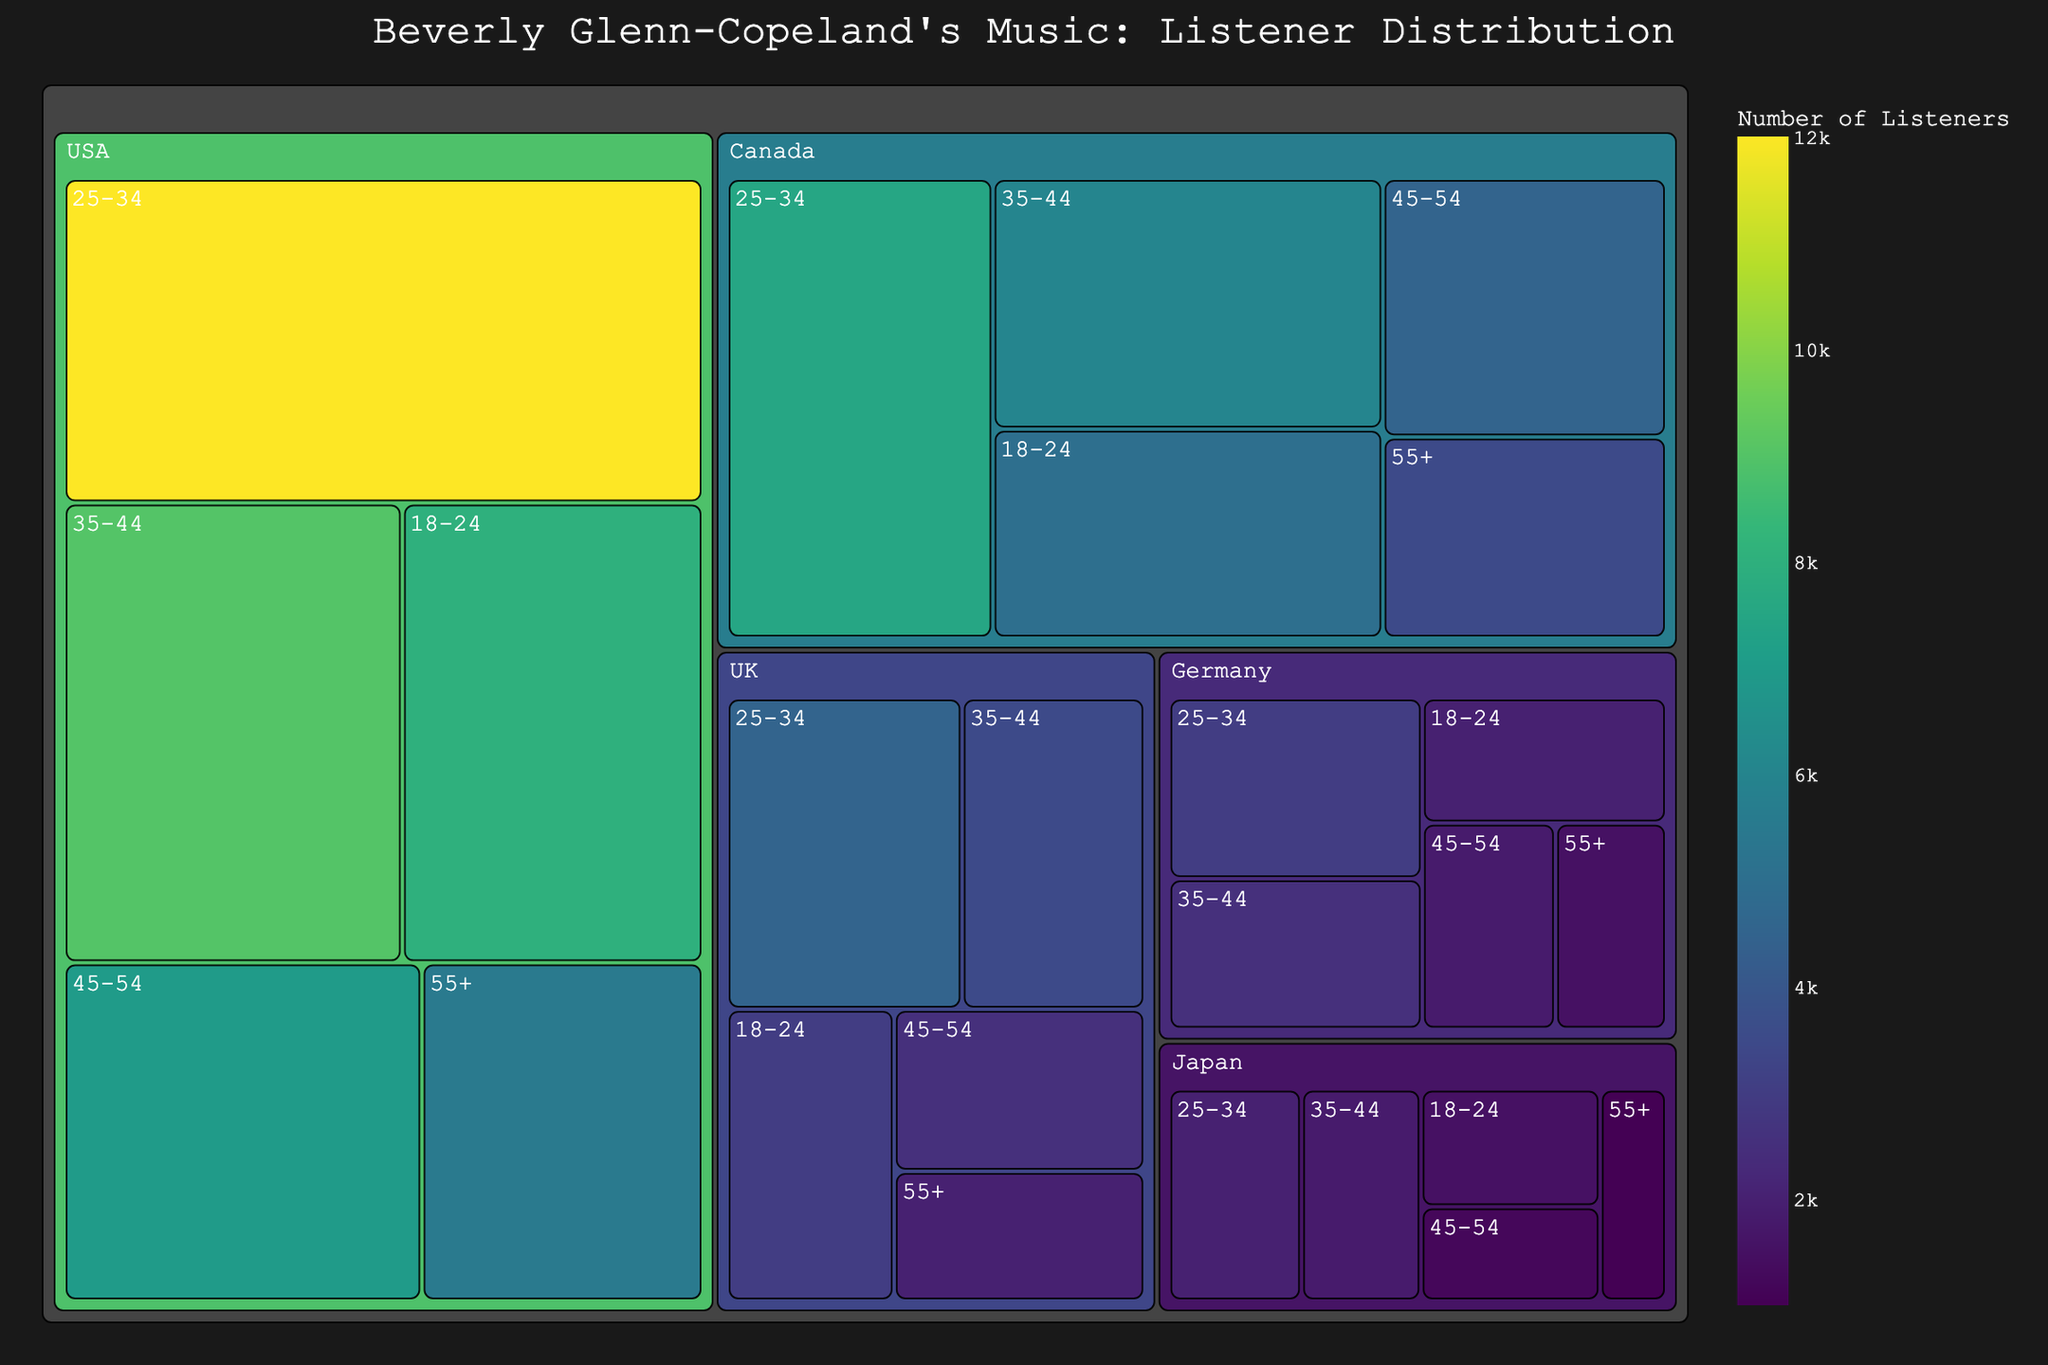What is the total number of listeners in Canada for Beverly Glenn-Copeland's music? Sum of Canadian listeners: 5000 (18-24) + 7500 (25-34) + 6000 (35-44) + 4500 (45-54) + 3500 (55+) = 26500
Answer: 26500 Which age group in the USA has the highest number of listeners? The USA age group with the highest number of listeners is 25-34 with 12000 listeners.
Answer: 25-34 Which country has the fewest listeners for the 55+ age group? Japan has the fewest listeners in the 55+ age group with 1000 listeners.
Answer: Japan How many more listeners are there in the UK's largest age group compared to its smallest age group? The UK's largest age group is 25-34 with 4500 listeners, and the smallest is 55+ with 2000 listeners. Difference: 4500 - 2000 = 2500
Answer: 2500 What is the proportion of listeners in the 18-24 age group in Germany compared to the total number of German listeners? Total listeners in Germany: 2000 (18-24) + 3000 (25-34) + 2500 (35-44) + 1800 (45-54) + 1500 (55+) = 10800. Proportion: 2000 / 10800 * 100% = 18.52%
Answer: 18.52% In which age group does Japan have the second lowest number of listeners? The second lowest number of listeners in Japan is in the 45-54 age group with 1200 listeners.
Answer: 45-54 Compare the total number of listeners in Canada and the USA. Which country has more listeners? Total listeners in Canada: 26500. Total listeners in the USA: 41500. The USA has more listeners.
Answer: USA Which country has the highest total number of listeners? The country with the highest total number of listeners is the USA with 41500 listeners.
Answer: USA 